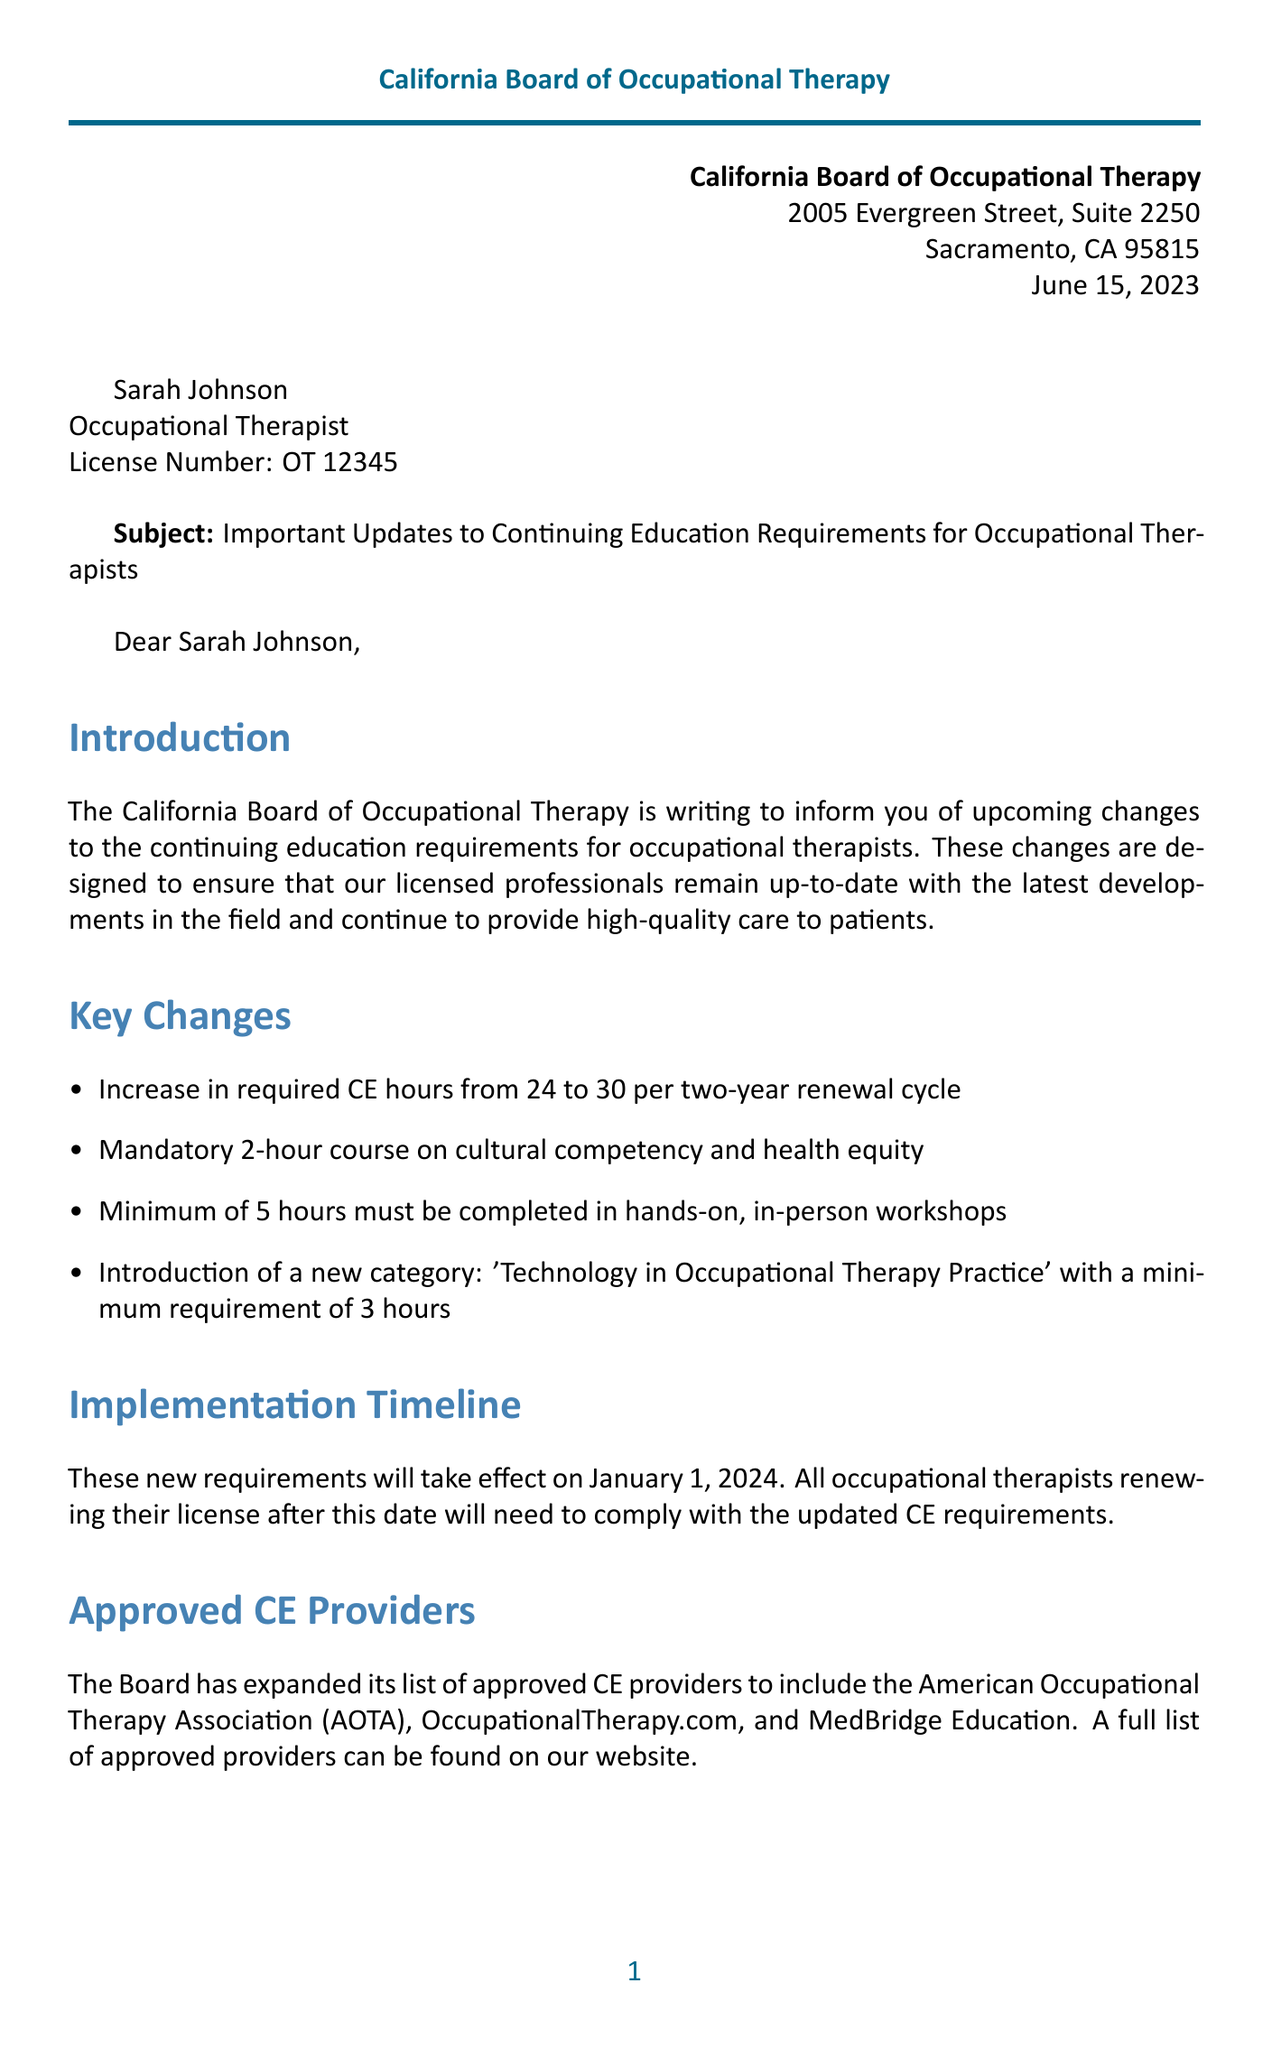What is the sender's name? The sender is identified as the California Board of Occupational Therapy.
Answer: California Board of Occupational Therapy What is the increase in required CE hours? The letter states that the required CE hours will increase from 24 to 30 per two-year renewal cycle.
Answer: 30 When will the new requirements take effect? The implementation timeline indicates that the new requirements will take effect on January 1, 2024.
Answer: January 1, 2024 How many hours are required for the new course on cultural competency? The letter specifies that the course on cultural competency and health equity is mandatory for 2 hours.
Answer: 2 hours What is the minimum number of hours for hands-on workshops? The document mentions that a minimum of 5 hours must be completed in hands-on, in-person workshops.
Answer: 5 hours What category has been newly introduced for CE requirements? The letter mentions the introduction of a new category called 'Technology in Occupational Therapy Practice'.
Answer: Technology in Occupational Therapy Practice How can occupational therapists register for the webinar? The document states that registration for the webinar can be completed on their website.
Answer: www.bot.ca.gov/ce-webinar Who is the signatory of the letter? The letter is signed by Dr. Lisa Martinez, who holds the title of Executive Officer.
Answer: Dr. Lisa Martinez What is the email address for the CE department? The letter provides the contact email for the CE department as ce@bot.ca.gov.
Answer: ce@bot.ca.gov 